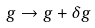<formula> <loc_0><loc_0><loc_500><loc_500>g \to g + \delta g</formula> 